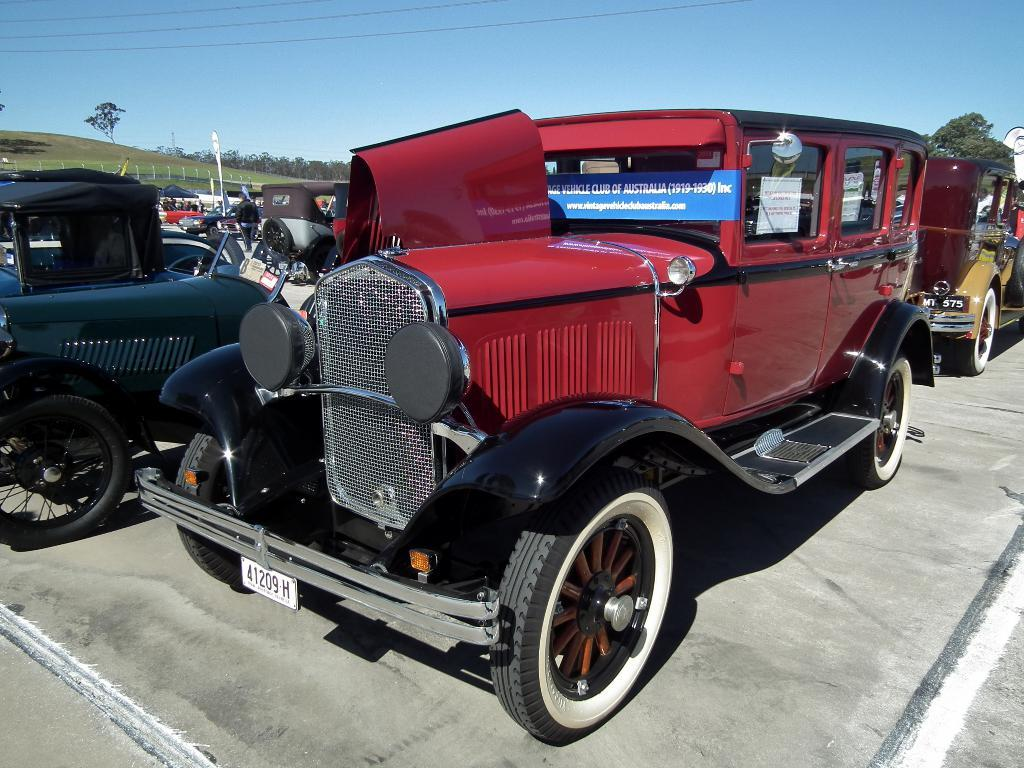Where was the picture taken? The picture was taken outside. What can be seen on the ground in the image? There is a group of vehicles parked on the ground. What is visible in the background of the image? The sky, trees, and green grass are visible in the background. What type of underwear is the tree wearing in the image? Trees do not wear underwear, as they are not living beings that require clothing. 